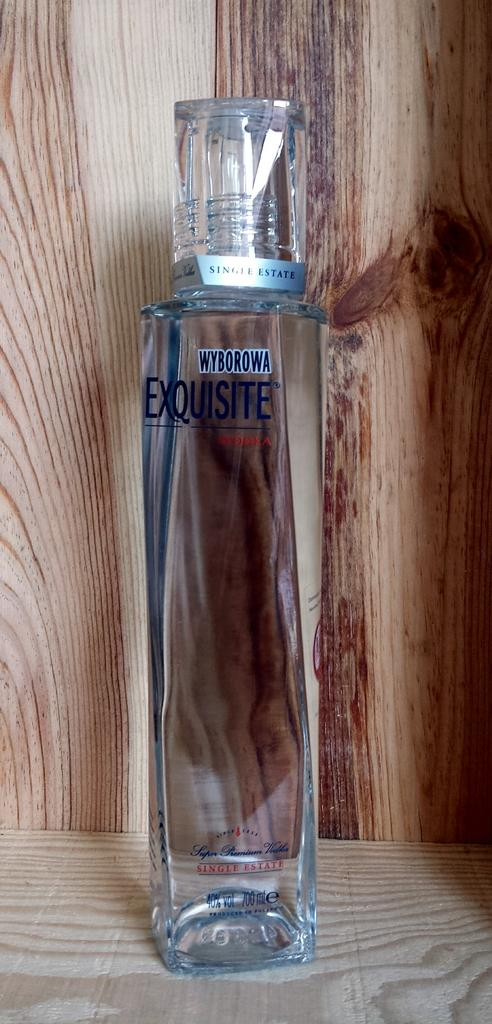Provide a one-sentence caption for the provided image. A bottle of vodka that is from the brand Wyborowa. 